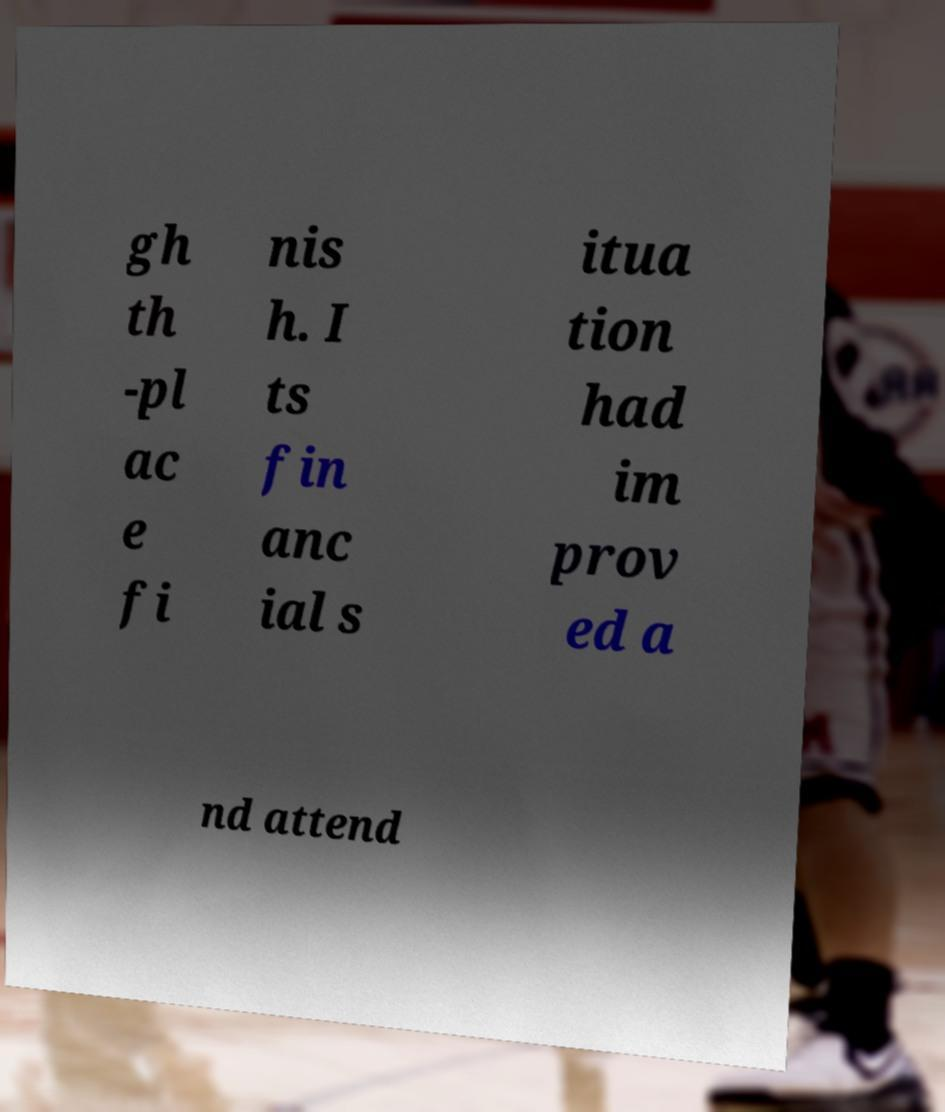There's text embedded in this image that I need extracted. Can you transcribe it verbatim? gh th -pl ac e fi nis h. I ts fin anc ial s itua tion had im prov ed a nd attend 